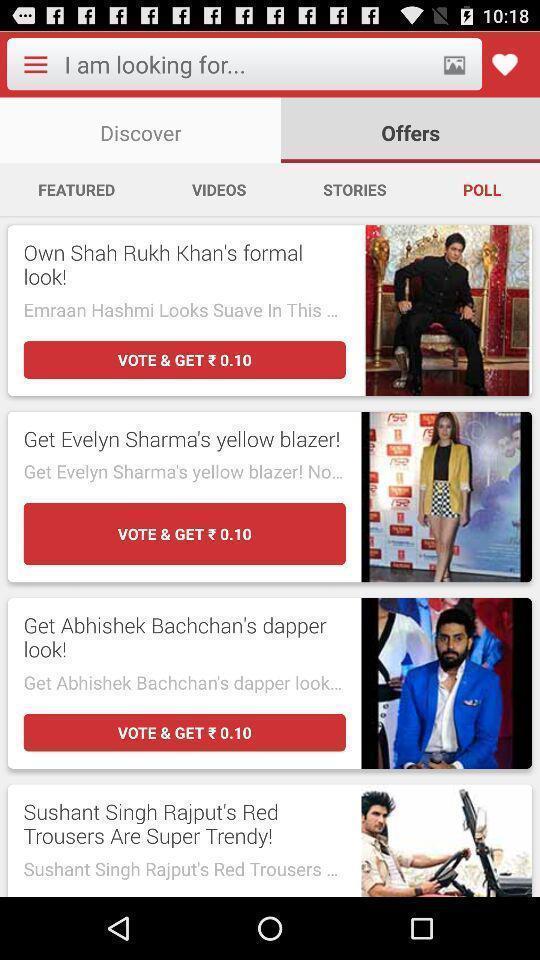Describe this image in words. Searching option to find fashion trends and offer details. 